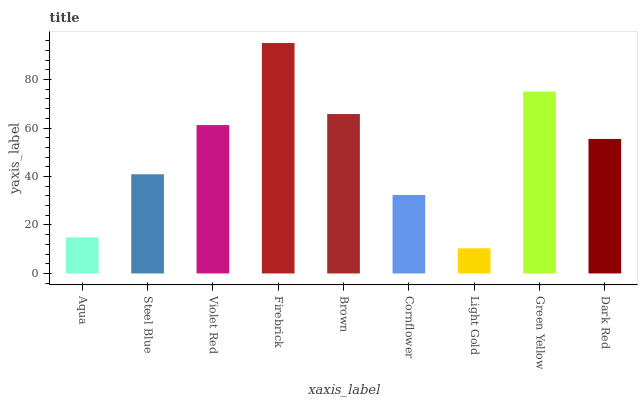Is Light Gold the minimum?
Answer yes or no. Yes. Is Firebrick the maximum?
Answer yes or no. Yes. Is Steel Blue the minimum?
Answer yes or no. No. Is Steel Blue the maximum?
Answer yes or no. No. Is Steel Blue greater than Aqua?
Answer yes or no. Yes. Is Aqua less than Steel Blue?
Answer yes or no. Yes. Is Aqua greater than Steel Blue?
Answer yes or no. No. Is Steel Blue less than Aqua?
Answer yes or no. No. Is Dark Red the high median?
Answer yes or no. Yes. Is Dark Red the low median?
Answer yes or no. Yes. Is Firebrick the high median?
Answer yes or no. No. Is Aqua the low median?
Answer yes or no. No. 